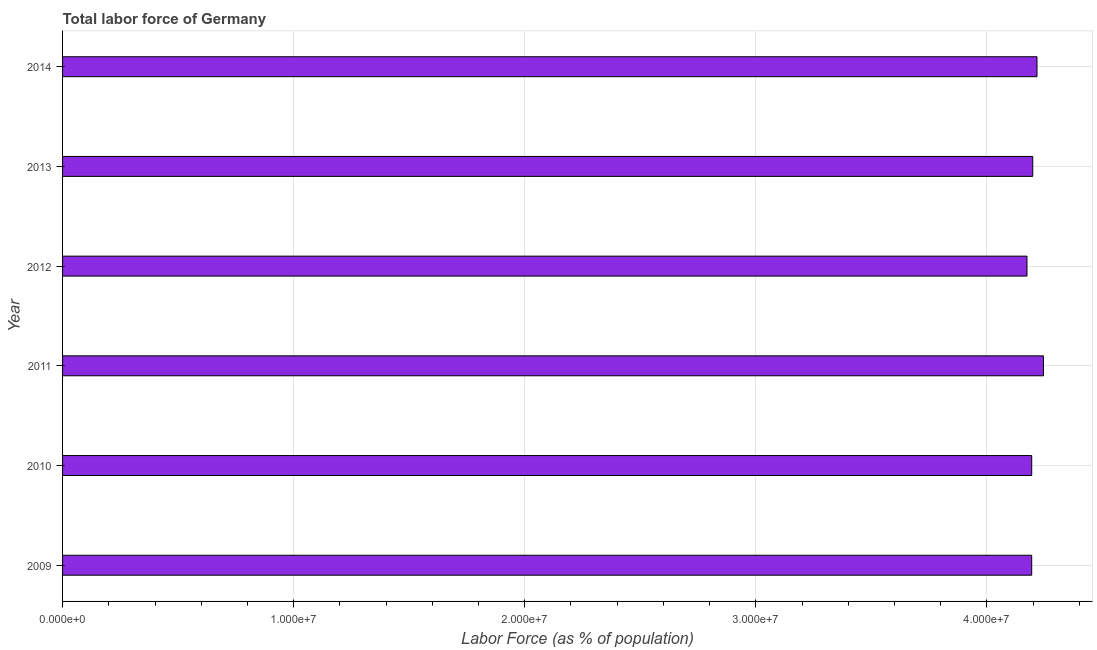Does the graph contain any zero values?
Keep it short and to the point. No. What is the title of the graph?
Provide a succinct answer. Total labor force of Germany. What is the label or title of the X-axis?
Offer a very short reply. Labor Force (as % of population). What is the total labor force in 2014?
Your answer should be very brief. 4.22e+07. Across all years, what is the maximum total labor force?
Offer a very short reply. 4.24e+07. Across all years, what is the minimum total labor force?
Your answer should be very brief. 4.17e+07. What is the sum of the total labor force?
Your answer should be very brief. 2.52e+08. What is the difference between the total labor force in 2009 and 2013?
Keep it short and to the point. -4.57e+04. What is the average total labor force per year?
Offer a very short reply. 4.20e+07. What is the median total labor force?
Provide a short and direct response. 4.20e+07. In how many years, is the total labor force greater than 22000000 %?
Provide a short and direct response. 6. Is the total labor force in 2009 less than that in 2012?
Give a very brief answer. No. What is the difference between the highest and the second highest total labor force?
Provide a succinct answer. 2.79e+05. Is the sum of the total labor force in 2011 and 2014 greater than the maximum total labor force across all years?
Your answer should be very brief. Yes. What is the difference between the highest and the lowest total labor force?
Keep it short and to the point. 7.12e+05. Are all the bars in the graph horizontal?
Keep it short and to the point. Yes. What is the difference between two consecutive major ticks on the X-axis?
Your answer should be very brief. 1.00e+07. Are the values on the major ticks of X-axis written in scientific E-notation?
Your answer should be very brief. Yes. What is the Labor Force (as % of population) of 2009?
Give a very brief answer. 4.19e+07. What is the Labor Force (as % of population) of 2010?
Ensure brevity in your answer.  4.19e+07. What is the Labor Force (as % of population) of 2011?
Give a very brief answer. 4.24e+07. What is the Labor Force (as % of population) of 2012?
Offer a very short reply. 4.17e+07. What is the Labor Force (as % of population) of 2013?
Your answer should be compact. 4.20e+07. What is the Labor Force (as % of population) of 2014?
Provide a succinct answer. 4.22e+07. What is the difference between the Labor Force (as % of population) in 2009 and 2010?
Your answer should be very brief. -866. What is the difference between the Labor Force (as % of population) in 2009 and 2011?
Give a very brief answer. -5.09e+05. What is the difference between the Labor Force (as % of population) in 2009 and 2012?
Your answer should be very brief. 2.04e+05. What is the difference between the Labor Force (as % of population) in 2009 and 2013?
Give a very brief answer. -4.57e+04. What is the difference between the Labor Force (as % of population) in 2009 and 2014?
Keep it short and to the point. -2.29e+05. What is the difference between the Labor Force (as % of population) in 2010 and 2011?
Your answer should be compact. -5.08e+05. What is the difference between the Labor Force (as % of population) in 2010 and 2012?
Your response must be concise. 2.05e+05. What is the difference between the Labor Force (as % of population) in 2010 and 2013?
Your response must be concise. -4.48e+04. What is the difference between the Labor Force (as % of population) in 2010 and 2014?
Provide a short and direct response. -2.28e+05. What is the difference between the Labor Force (as % of population) in 2011 and 2012?
Offer a very short reply. 7.12e+05. What is the difference between the Labor Force (as % of population) in 2011 and 2013?
Offer a very short reply. 4.63e+05. What is the difference between the Labor Force (as % of population) in 2011 and 2014?
Your answer should be compact. 2.79e+05. What is the difference between the Labor Force (as % of population) in 2012 and 2013?
Your response must be concise. -2.49e+05. What is the difference between the Labor Force (as % of population) in 2012 and 2014?
Offer a terse response. -4.33e+05. What is the difference between the Labor Force (as % of population) in 2013 and 2014?
Your answer should be very brief. -1.83e+05. What is the ratio of the Labor Force (as % of population) in 2009 to that in 2013?
Offer a terse response. 1. What is the ratio of the Labor Force (as % of population) in 2010 to that in 2011?
Your answer should be compact. 0.99. What is the ratio of the Labor Force (as % of population) in 2010 to that in 2013?
Give a very brief answer. 1. What is the ratio of the Labor Force (as % of population) in 2010 to that in 2014?
Provide a succinct answer. 0.99. What is the ratio of the Labor Force (as % of population) in 2011 to that in 2014?
Offer a very short reply. 1.01. What is the ratio of the Labor Force (as % of population) in 2012 to that in 2014?
Provide a succinct answer. 0.99. 